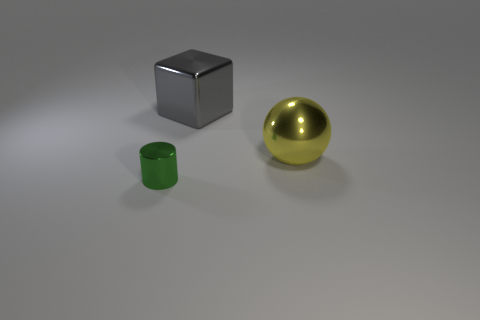Add 2 tiny green shiny balls. How many tiny green shiny balls exist? 2 Add 3 big metallic things. How many objects exist? 6 Subtract 0 cyan cylinders. How many objects are left? 3 Subtract all cylinders. How many objects are left? 2 Subtract all blue balls. Subtract all yellow cylinders. How many balls are left? 1 Subtract all blue cylinders. How many green spheres are left? 0 Subtract all tiny shiny things. Subtract all small purple matte cubes. How many objects are left? 2 Add 2 large gray shiny objects. How many large gray shiny objects are left? 3 